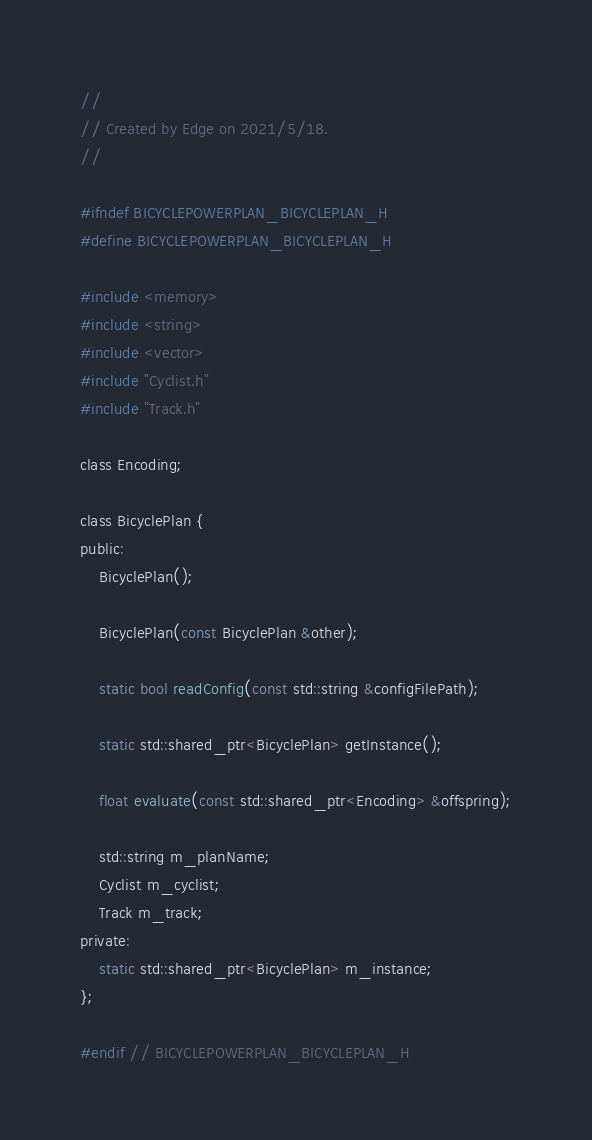<code> <loc_0><loc_0><loc_500><loc_500><_C_>//
// Created by Edge on 2021/5/18.
//

#ifndef BICYCLEPOWERPLAN_BICYCLEPLAN_H
#define BICYCLEPOWERPLAN_BICYCLEPLAN_H

#include <memory>
#include <string>
#include <vector>
#include "Cyclist.h"
#include "Track.h"

class Encoding;

class BicyclePlan {
public:
    BicyclePlan();

    BicyclePlan(const BicyclePlan &other);

    static bool readConfig(const std::string &configFilePath);

    static std::shared_ptr<BicyclePlan> getInstance();

    float evaluate(const std::shared_ptr<Encoding> &offspring);

    std::string m_planName;
    Cyclist m_cyclist;
    Track m_track;
private:
    static std::shared_ptr<BicyclePlan> m_instance;
};

#endif // BICYCLEPOWERPLAN_BICYCLEPLAN_H
</code> 